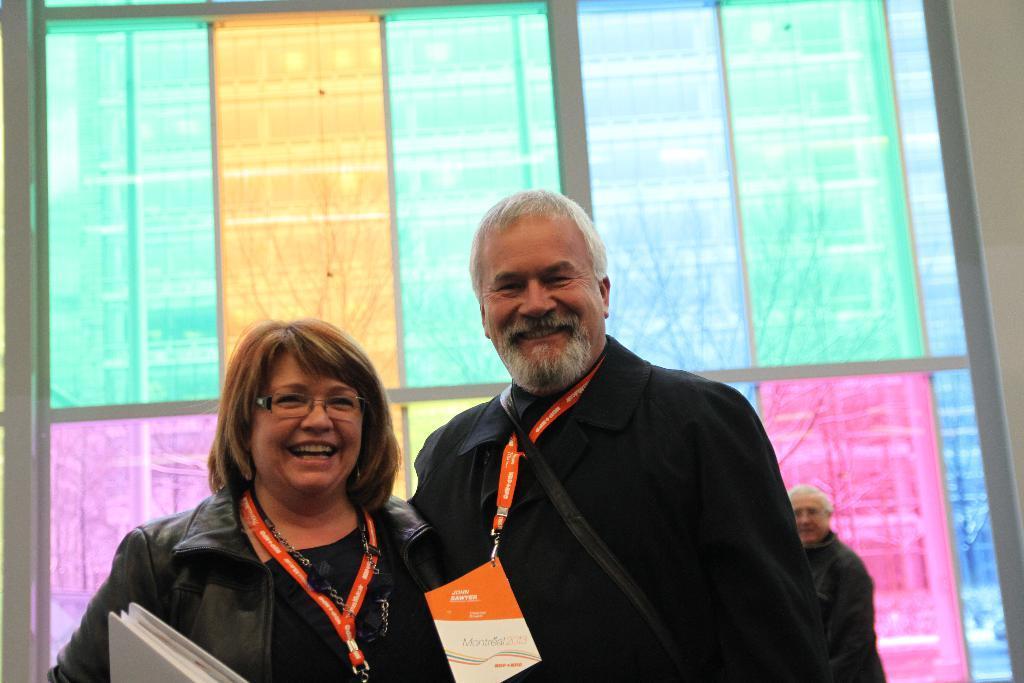Could you give a brief overview of what you see in this image? In this image in the front there are persons standing and smiling. On the left side there is a woman standing and holding a file which is white in colour in her hand and smiling. In the background there is a man standing and smiling and there is a glass with paintings on it. 